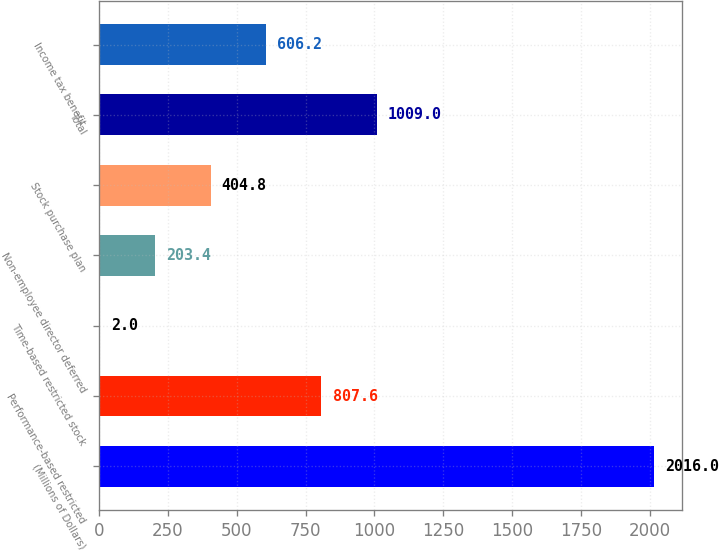Convert chart to OTSL. <chart><loc_0><loc_0><loc_500><loc_500><bar_chart><fcel>(Millions of Dollars)<fcel>Performance-based restricted<fcel>Time-based restricted stock<fcel>Non-employee director deferred<fcel>Stock purchase plan<fcel>Total<fcel>Income tax benefit<nl><fcel>2016<fcel>807.6<fcel>2<fcel>203.4<fcel>404.8<fcel>1009<fcel>606.2<nl></chart> 